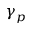Convert formula to latex. <formula><loc_0><loc_0><loc_500><loc_500>\gamma _ { p }</formula> 